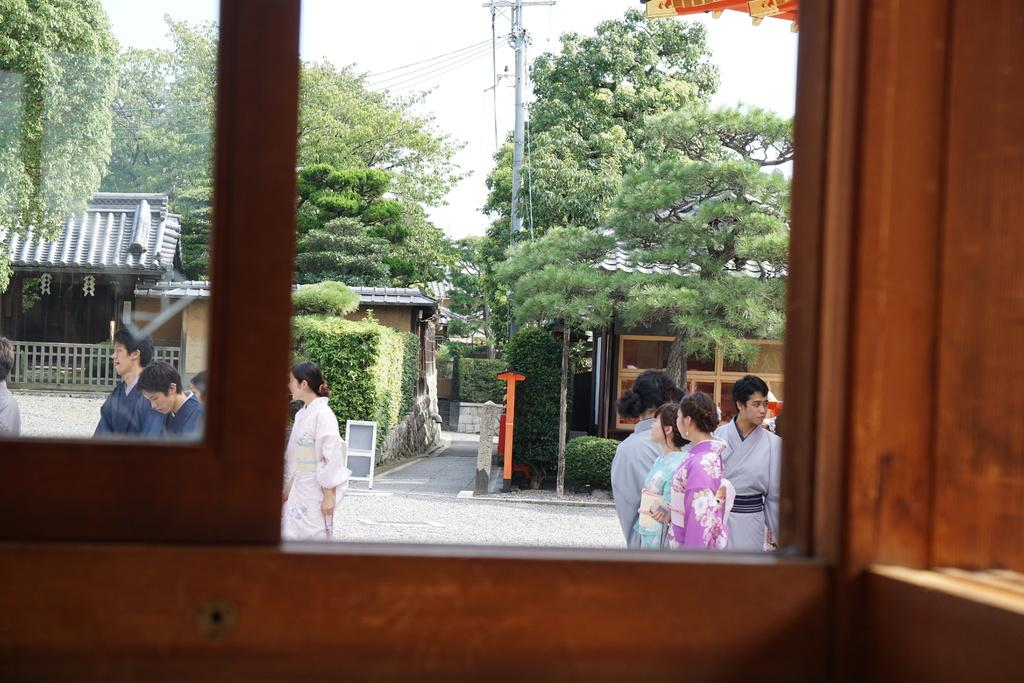What is the vantage point of the image? The image is taken from the view of a window. What can be seen outside the window? There are houses, trees, poles with wires, and a board on the road visible behind the window. Are there any living beings visible in the image? Yes, there are people visible in the image. What is visible in the sky in the image? The sky is visible in the image. What type of gold territory can be seen in the image? There is no gold territory present in the image. Can you tell me how many forks are visible in the image? There are no forks visible in the image. 